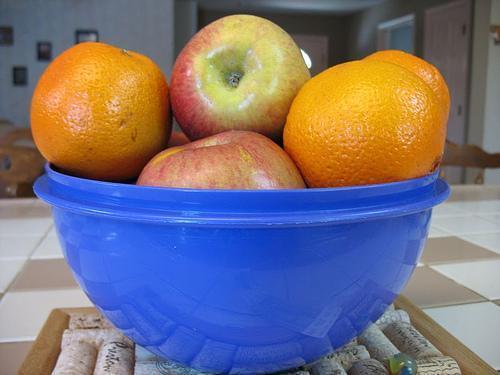How many oranges are there?
Give a very brief answer. 2. How many apples can you see?
Give a very brief answer. 2. 